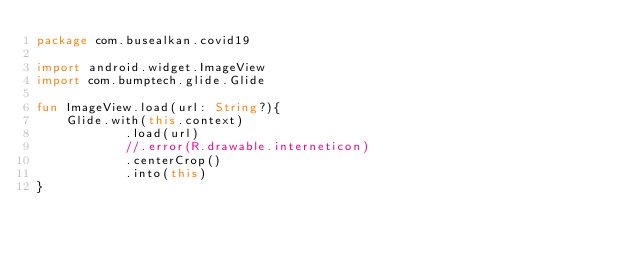Convert code to text. <code><loc_0><loc_0><loc_500><loc_500><_Kotlin_>package com.busealkan.covid19

import android.widget.ImageView
import com.bumptech.glide.Glide

fun ImageView.load(url: String?){
    Glide.with(this.context)
            .load(url)
            //.error(R.drawable.interneticon)
            .centerCrop()
            .into(this)
}




</code> 